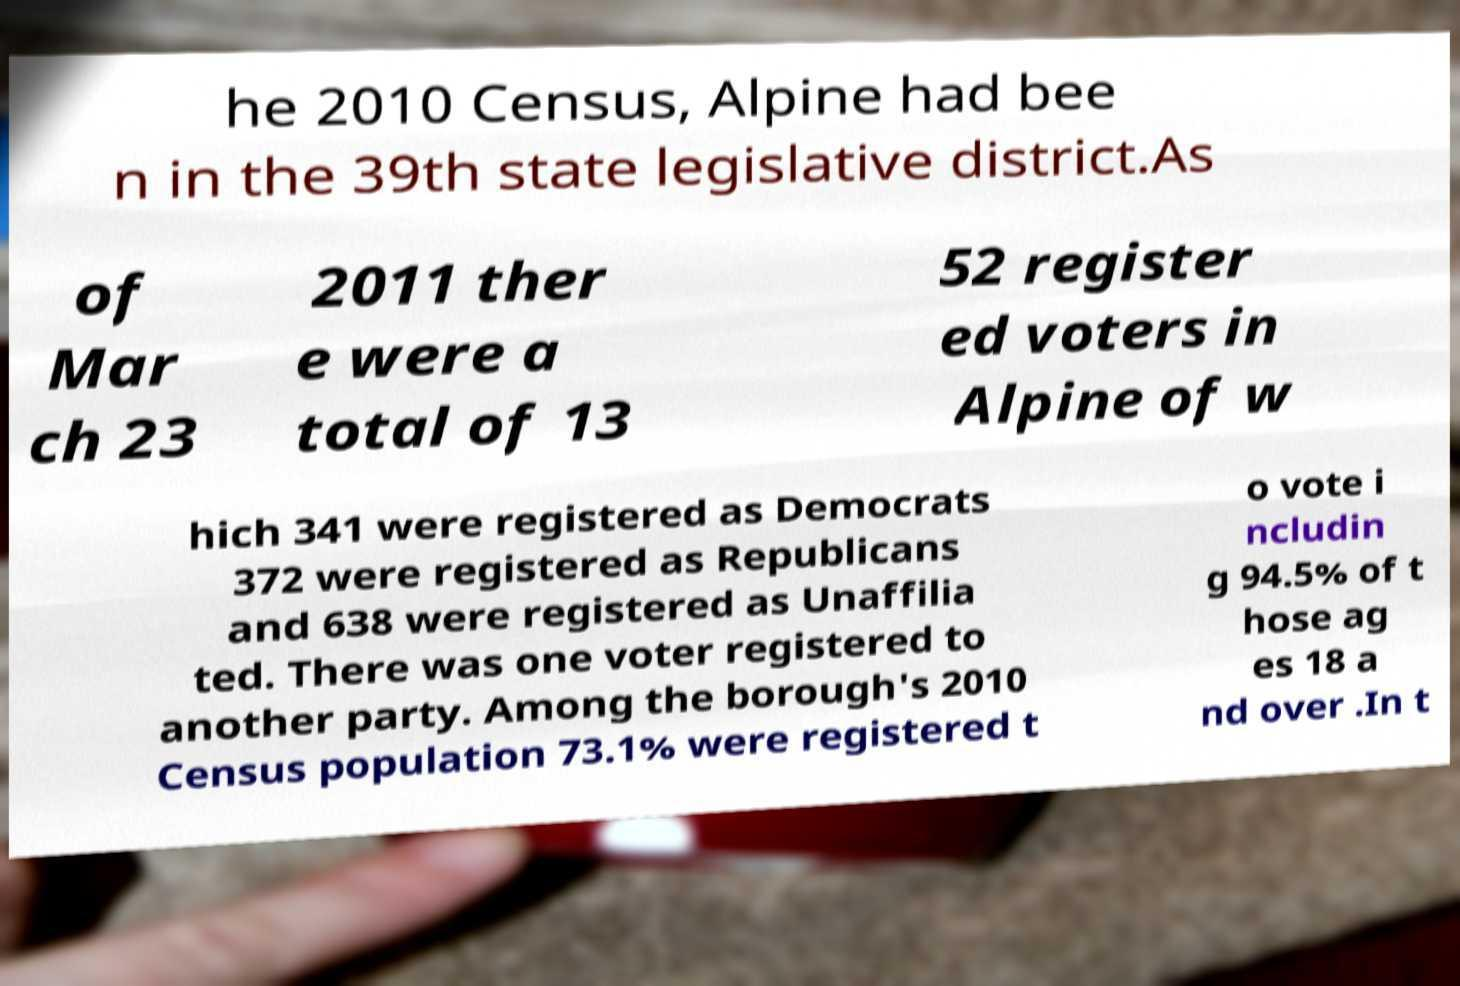Please identify and transcribe the text found in this image. he 2010 Census, Alpine had bee n in the 39th state legislative district.As of Mar ch 23 2011 ther e were a total of 13 52 register ed voters in Alpine of w hich 341 were registered as Democrats 372 were registered as Republicans and 638 were registered as Unaffilia ted. There was one voter registered to another party. Among the borough's 2010 Census population 73.1% were registered t o vote i ncludin g 94.5% of t hose ag es 18 a nd over .In t 